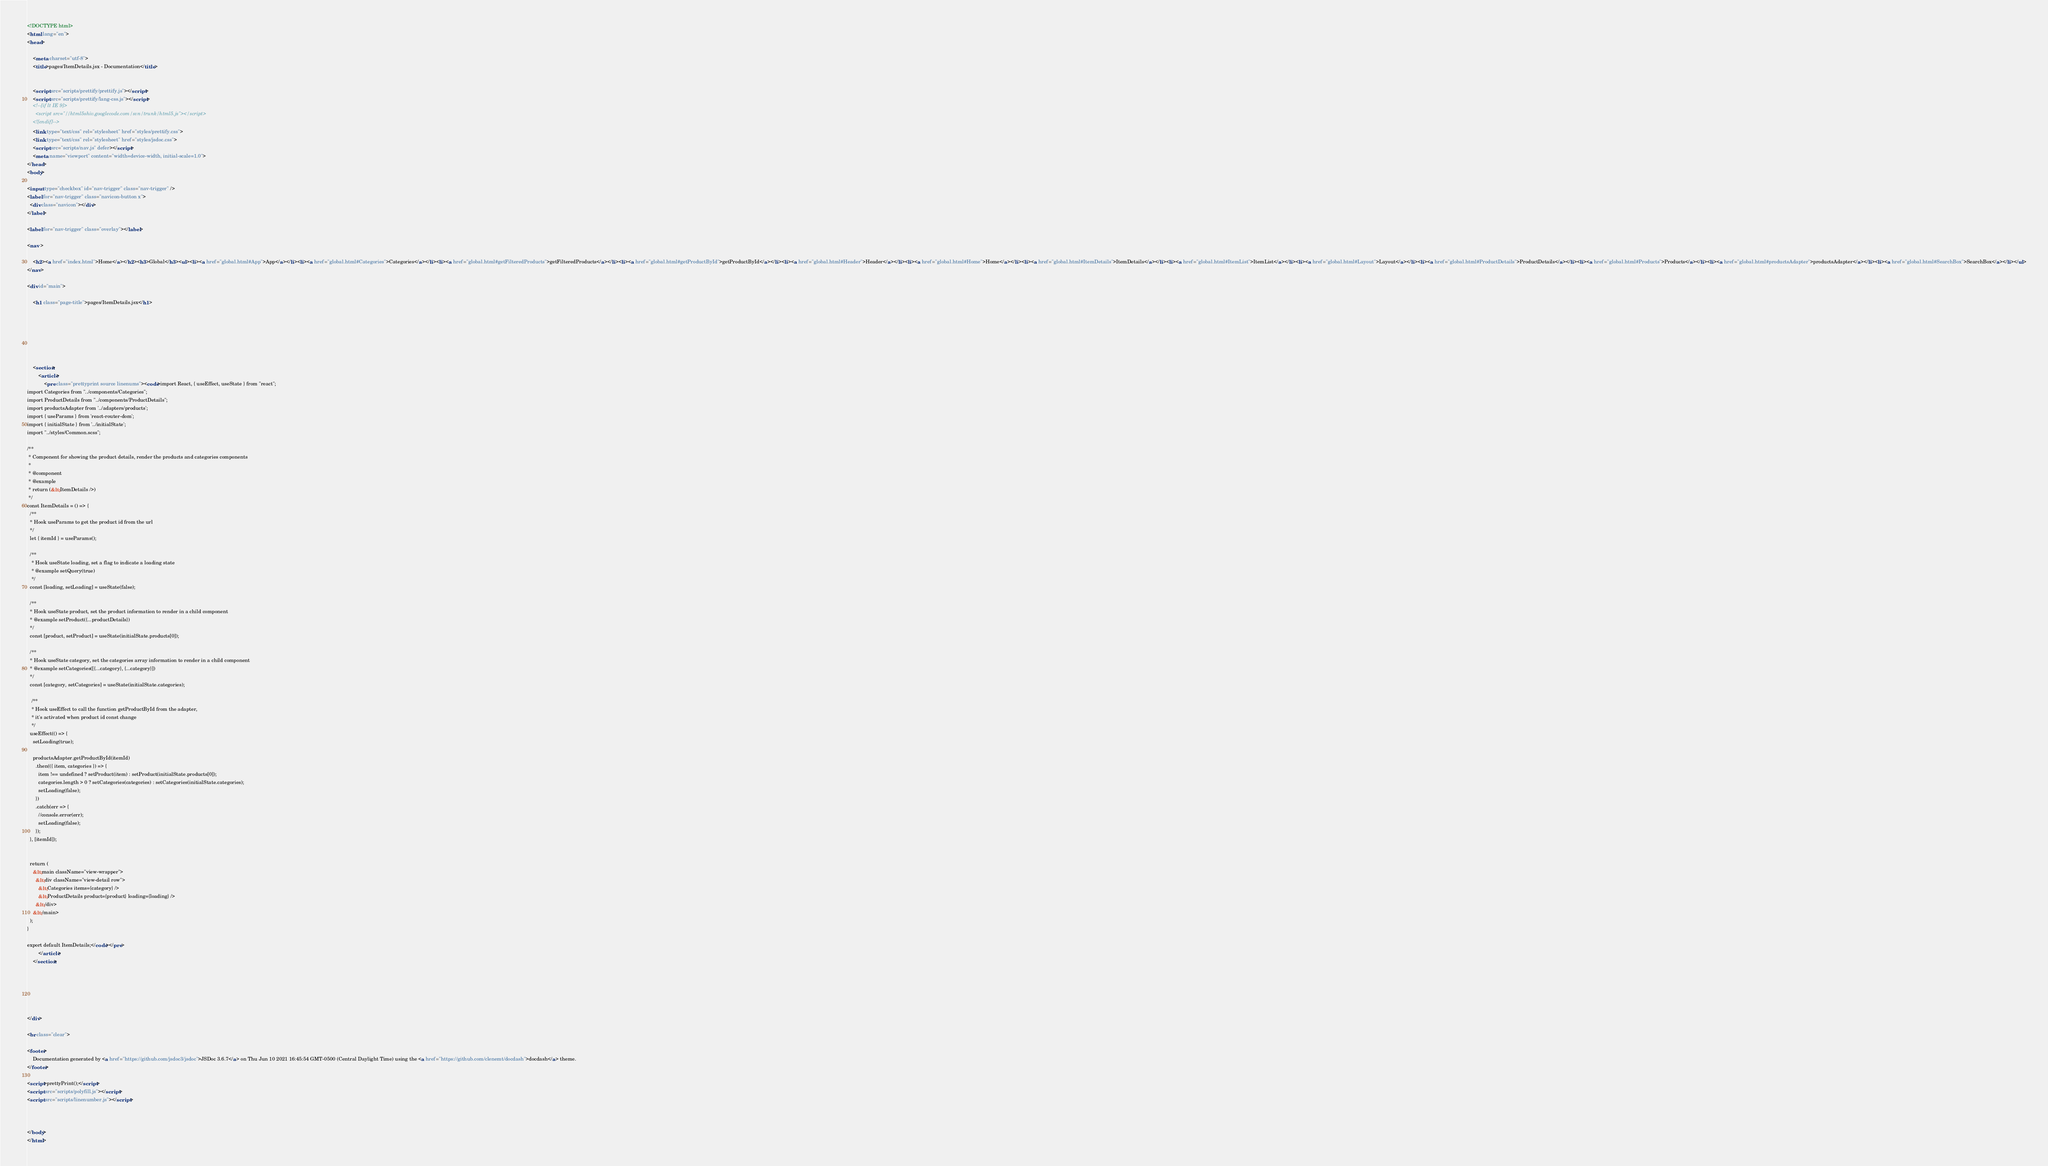Convert code to text. <code><loc_0><loc_0><loc_500><loc_500><_HTML_><!DOCTYPE html>
<html lang="en">
<head>
    
    <meta charset="utf-8">
    <title>pages/ItemDetails.jsx - Documentation</title>
    
    
    <script src="scripts/prettify/prettify.js"></script>
    <script src="scripts/prettify/lang-css.js"></script>
    <!--[if lt IE 9]>
      <script src="//html5shiv.googlecode.com/svn/trunk/html5.js"></script>
    <![endif]-->
    <link type="text/css" rel="stylesheet" href="styles/prettify.css">
    <link type="text/css" rel="stylesheet" href="styles/jsdoc.css">
    <script src="scripts/nav.js" defer></script>
    <meta name="viewport" content="width=device-width, initial-scale=1.0">
</head>
<body>

<input type="checkbox" id="nav-trigger" class="nav-trigger" />
<label for="nav-trigger" class="navicon-button x">
  <div class="navicon"></div>
</label>

<label for="nav-trigger" class="overlay"></label>

<nav >
    
    <h2><a href="index.html">Home</a></h2><h3>Global</h3><ul><li><a href="global.html#App">App</a></li><li><a href="global.html#Categories">Categories</a></li><li><a href="global.html#getFilteredProducts">getFilteredProducts</a></li><li><a href="global.html#getProductById">getProductById</a></li><li><a href="global.html#Header">Header</a></li><li><a href="global.html#Home">Home</a></li><li><a href="global.html#ItemDetails">ItemDetails</a></li><li><a href="global.html#ItemList">ItemList</a></li><li><a href="global.html#Layout">Layout</a></li><li><a href="global.html#ProductDetails">ProductDetails</a></li><li><a href="global.html#Products">Products</a></li><li><a href="global.html#productsAdapter">productsAdapter</a></li><li><a href="global.html#SearchBox">SearchBox</a></li></ul>
</nav>

<div id="main">
    
    <h1 class="page-title">pages/ItemDetails.jsx</h1>
    

    



    
    <section>
        <article>
            <pre class="prettyprint source linenums"><code>import React, { useEffect, useState } from "react";
import Categories from "../components/Categories";
import ProductDetails from "../components/ProductDetails";
import productsAdapter from '../adapters/products';
import { useParams } from 'react-router-dom';
import { initialState } from '../initialState';
import "../styles/Common.scss";

/**
 * Component for showing the product details, render the products and categories components
 * 
 * @component
 * @example
 * return (&lt;ItemDetails />)
 */
const ItemDetails = () => {
  /**
  * Hook useParams to get the product id from the url 
  */
  let { itemId } = useParams();

  /**
   * Hook useState loading, set a flag to indicate a loading state
   * @example setQuery(true)
   */
  const [loading, setLoading] = useState(false);

  /**
  * Hook useState product, set the product information to render in a child component
  * @example setProduct({...productDetails})
  */
  const [product, setProduct] = useState(initialState.products[0]);
  
  /**
  * Hook useState category, set the categories array information to render in a child component
  * @example setCategories([{...category}, {...category}])
  */
  const [category, setCategories] = useState(initialState.categories);

   /**
   * Hook useEffect to call the function getProductById from the adapter,
   * it's activated when product id const change 
   */
  useEffect(() => {
    setLoading(true);

    productsAdapter.getProductById(itemId)
      .then(({ item, categories }) => {
        item !== undefined ? setProduct(item) : setProduct(initialState.products[0]);
        categories.length > 0 ? setCategories(categories) : setCategories(initialState.categories);
        setLoading(false);
      })
      .catch(err => {
        //console.error(err);
        setLoading(false);
      });
  }, [itemId]);


  return (
    &lt;main className="view-wrapper">
      &lt;div className="view-detail row">
        &lt;Categories items={category} />
        &lt;ProductDetails product={product} loading={loading} />
      &lt;/div>
    &lt;/main>
  );
}

export default ItemDetails;</code></pre>
        </article>
    </section>




    
    
</div>

<br class="clear">

<footer>
    Documentation generated by <a href="https://github.com/jsdoc3/jsdoc">JSDoc 3.6.7</a> on Thu Jun 10 2021 16:45:54 GMT-0500 (Central Daylight Time) using the <a href="https://github.com/clenemt/docdash">docdash</a> theme.
</footer>

<script>prettyPrint();</script>
<script src="scripts/polyfill.js"></script>
<script src="scripts/linenumber.js"></script>



</body>
</html>
</code> 